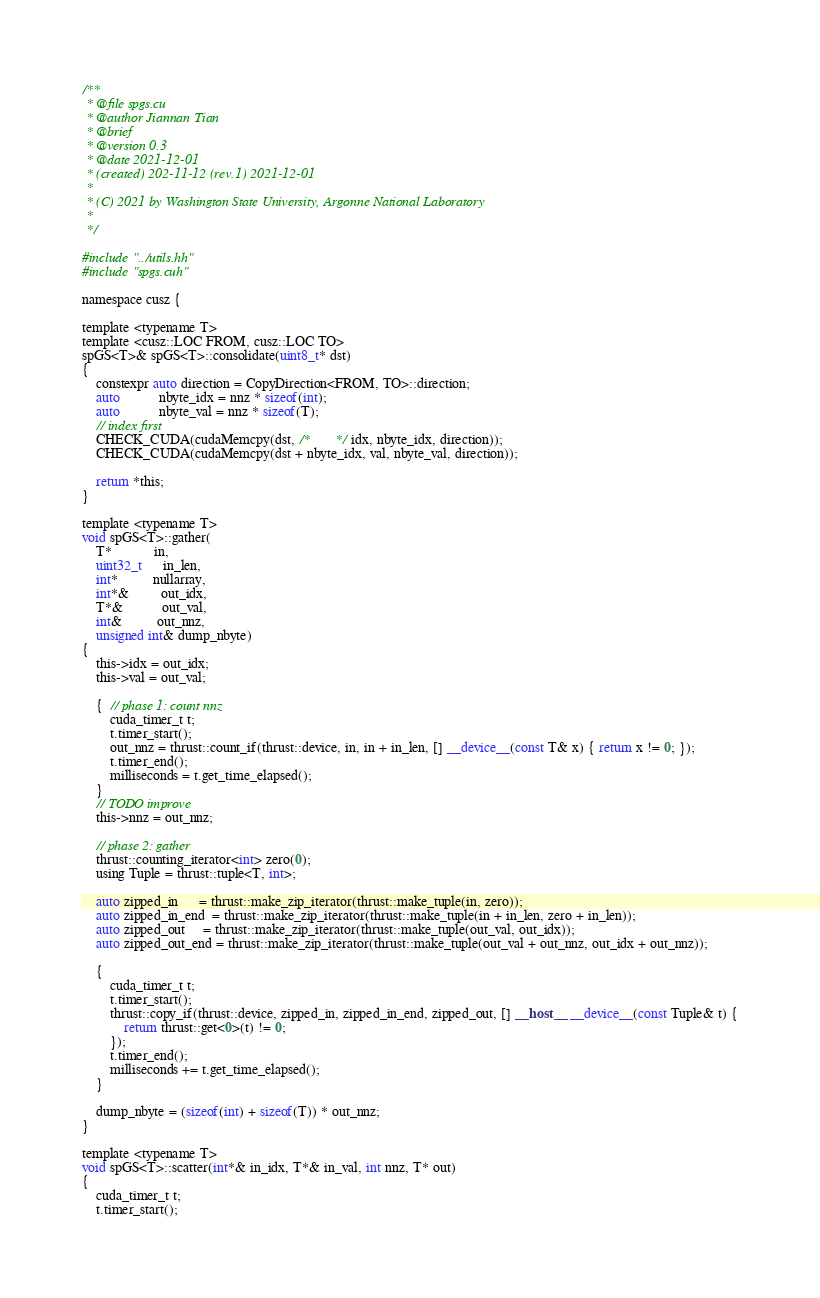<code> <loc_0><loc_0><loc_500><loc_500><_Cuda_>/**
 * @file spgs.cu
 * @author Jiannan Tian
 * @brief
 * @version 0.3
 * @date 2021-12-01
 * (created) 202-11-12 (rev.1) 2021-12-01
 *
 * (C) 2021 by Washington State University, Argonne National Laboratory
 *
 */

#include "../utils.hh"
#include "spgs.cuh"

namespace cusz {

template <typename T>
template <cusz::LOC FROM, cusz::LOC TO>
spGS<T>& spGS<T>::consolidate(uint8_t* dst)
{
    constexpr auto direction = CopyDirection<FROM, TO>::direction;
    auto           nbyte_idx = nnz * sizeof(int);
    auto           nbyte_val = nnz * sizeof(T);
    // index first
    CHECK_CUDA(cudaMemcpy(dst, /*       */ idx, nbyte_idx, direction));
    CHECK_CUDA(cudaMemcpy(dst + nbyte_idx, val, nbyte_val, direction));

    return *this;
}

template <typename T>
void spGS<T>::gather(
    T*            in,
    uint32_t      in_len,
    int*          nullarray,
    int*&         out_idx,
    T*&           out_val,
    int&          out_nnz,
    unsigned int& dump_nbyte)
{
    this->idx = out_idx;
    this->val = out_val;

    {  // phase 1: count nnz
        cuda_timer_t t;
        t.timer_start();
        out_nnz = thrust::count_if(thrust::device, in, in + in_len, [] __device__(const T& x) { return x != 0; });
        t.timer_end();
        milliseconds = t.get_time_elapsed();
    }
    // TODO improve
    this->nnz = out_nnz;

    // phase 2: gather
    thrust::counting_iterator<int> zero(0);
    using Tuple = thrust::tuple<T, int>;

    auto zipped_in      = thrust::make_zip_iterator(thrust::make_tuple(in, zero));
    auto zipped_in_end  = thrust::make_zip_iterator(thrust::make_tuple(in + in_len, zero + in_len));
    auto zipped_out     = thrust::make_zip_iterator(thrust::make_tuple(out_val, out_idx));
    auto zipped_out_end = thrust::make_zip_iterator(thrust::make_tuple(out_val + out_nnz, out_idx + out_nnz));

    {
        cuda_timer_t t;
        t.timer_start();
        thrust::copy_if(thrust::device, zipped_in, zipped_in_end, zipped_out, [] __host__ __device__(const Tuple& t) {
            return thrust::get<0>(t) != 0;
        });
        t.timer_end();
        milliseconds += t.get_time_elapsed();
    }

    dump_nbyte = (sizeof(int) + sizeof(T)) * out_nnz;
}

template <typename T>
void spGS<T>::scatter(int*& in_idx, T*& in_val, int nnz, T* out)
{
    cuda_timer_t t;
    t.timer_start();</code> 